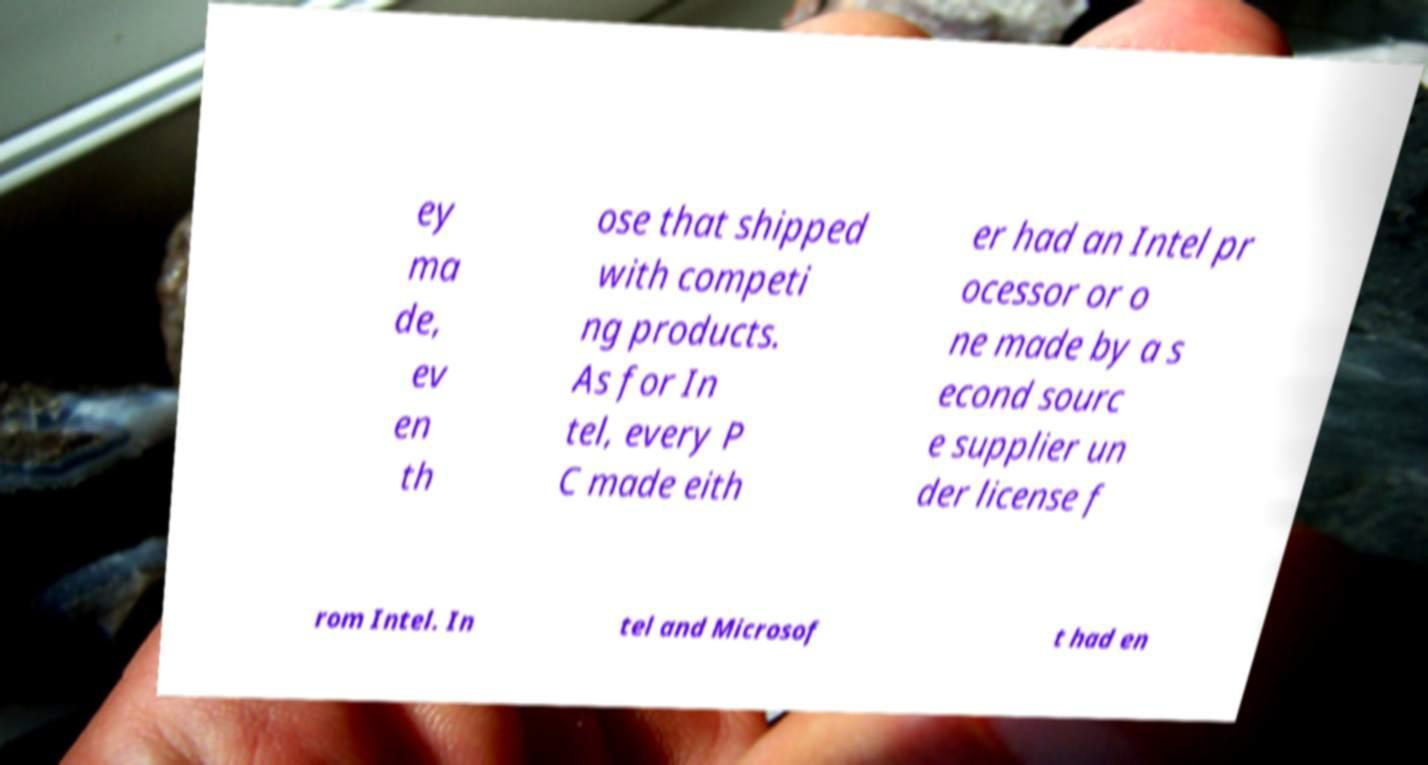Please read and relay the text visible in this image. What does it say? ey ma de, ev en th ose that shipped with competi ng products. As for In tel, every P C made eith er had an Intel pr ocessor or o ne made by a s econd sourc e supplier un der license f rom Intel. In tel and Microsof t had en 